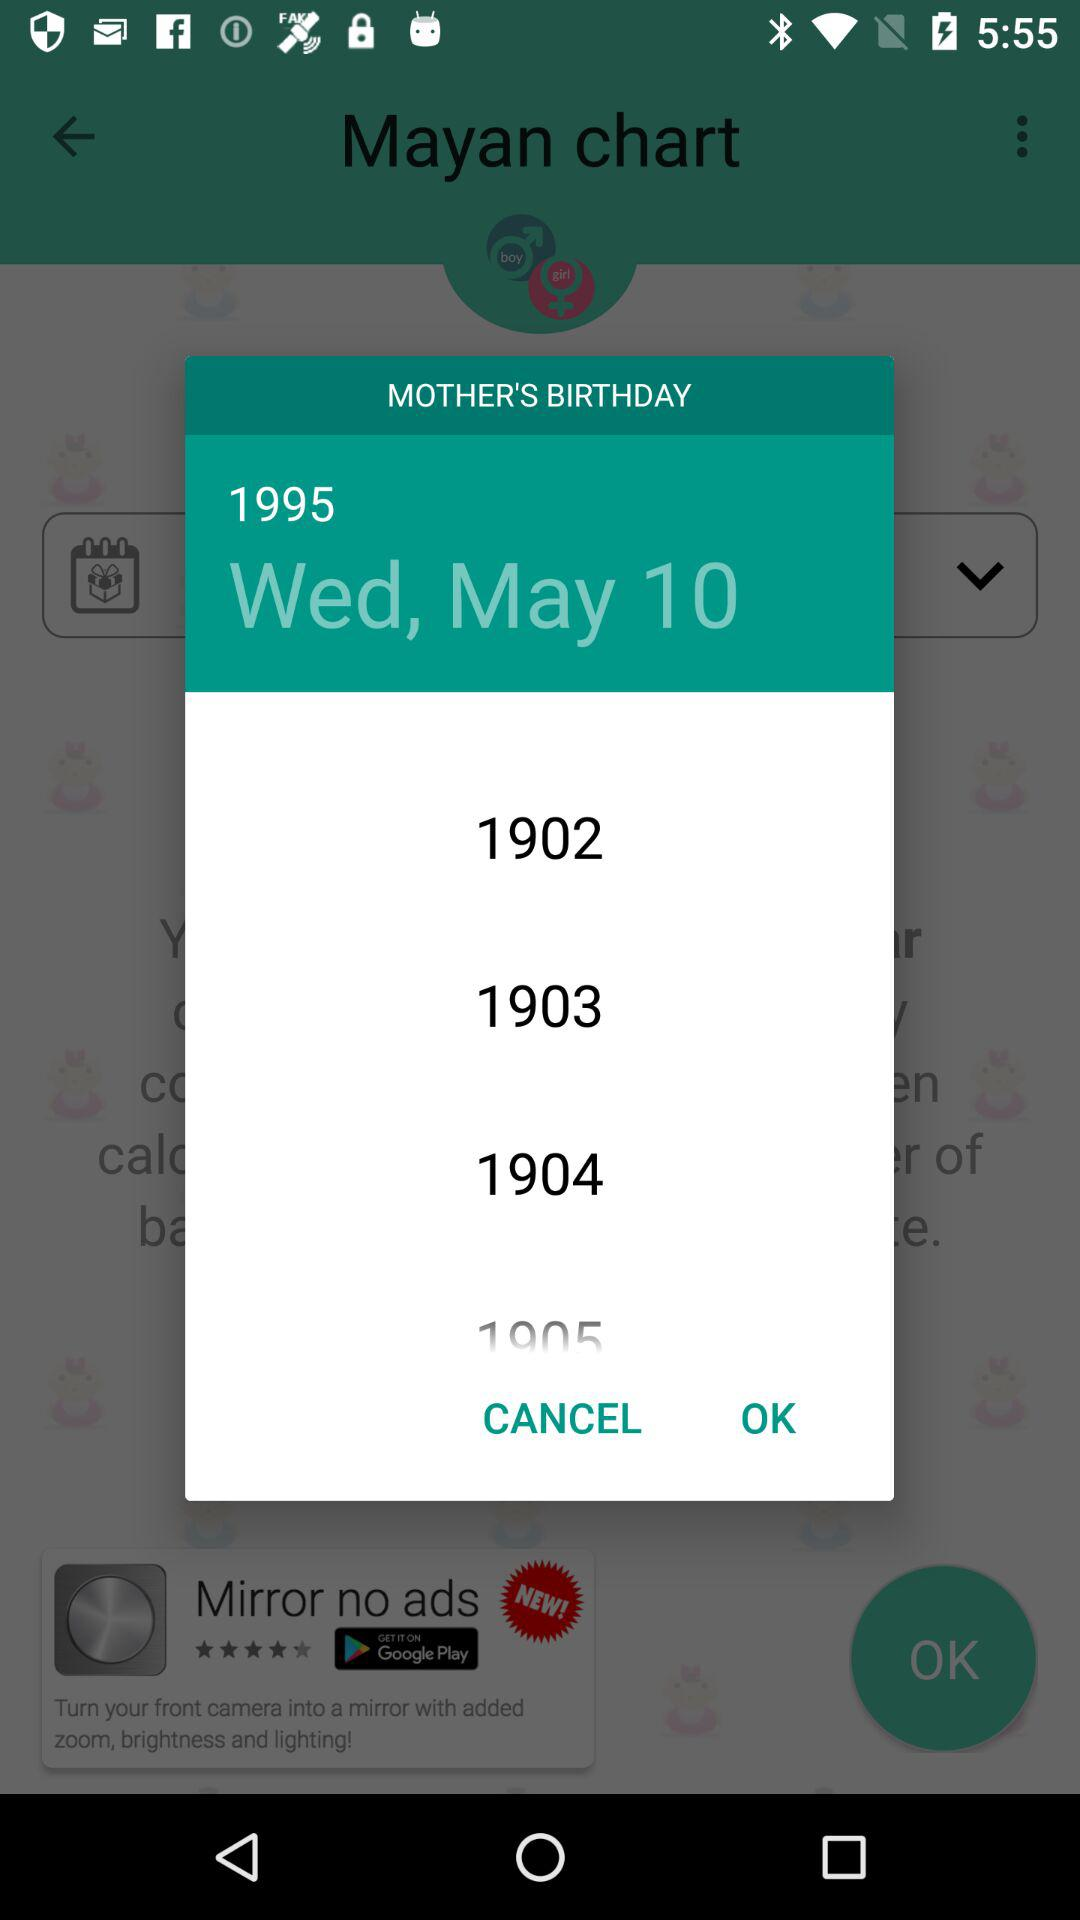What day is it on the selected date? The day is Wednesday. 